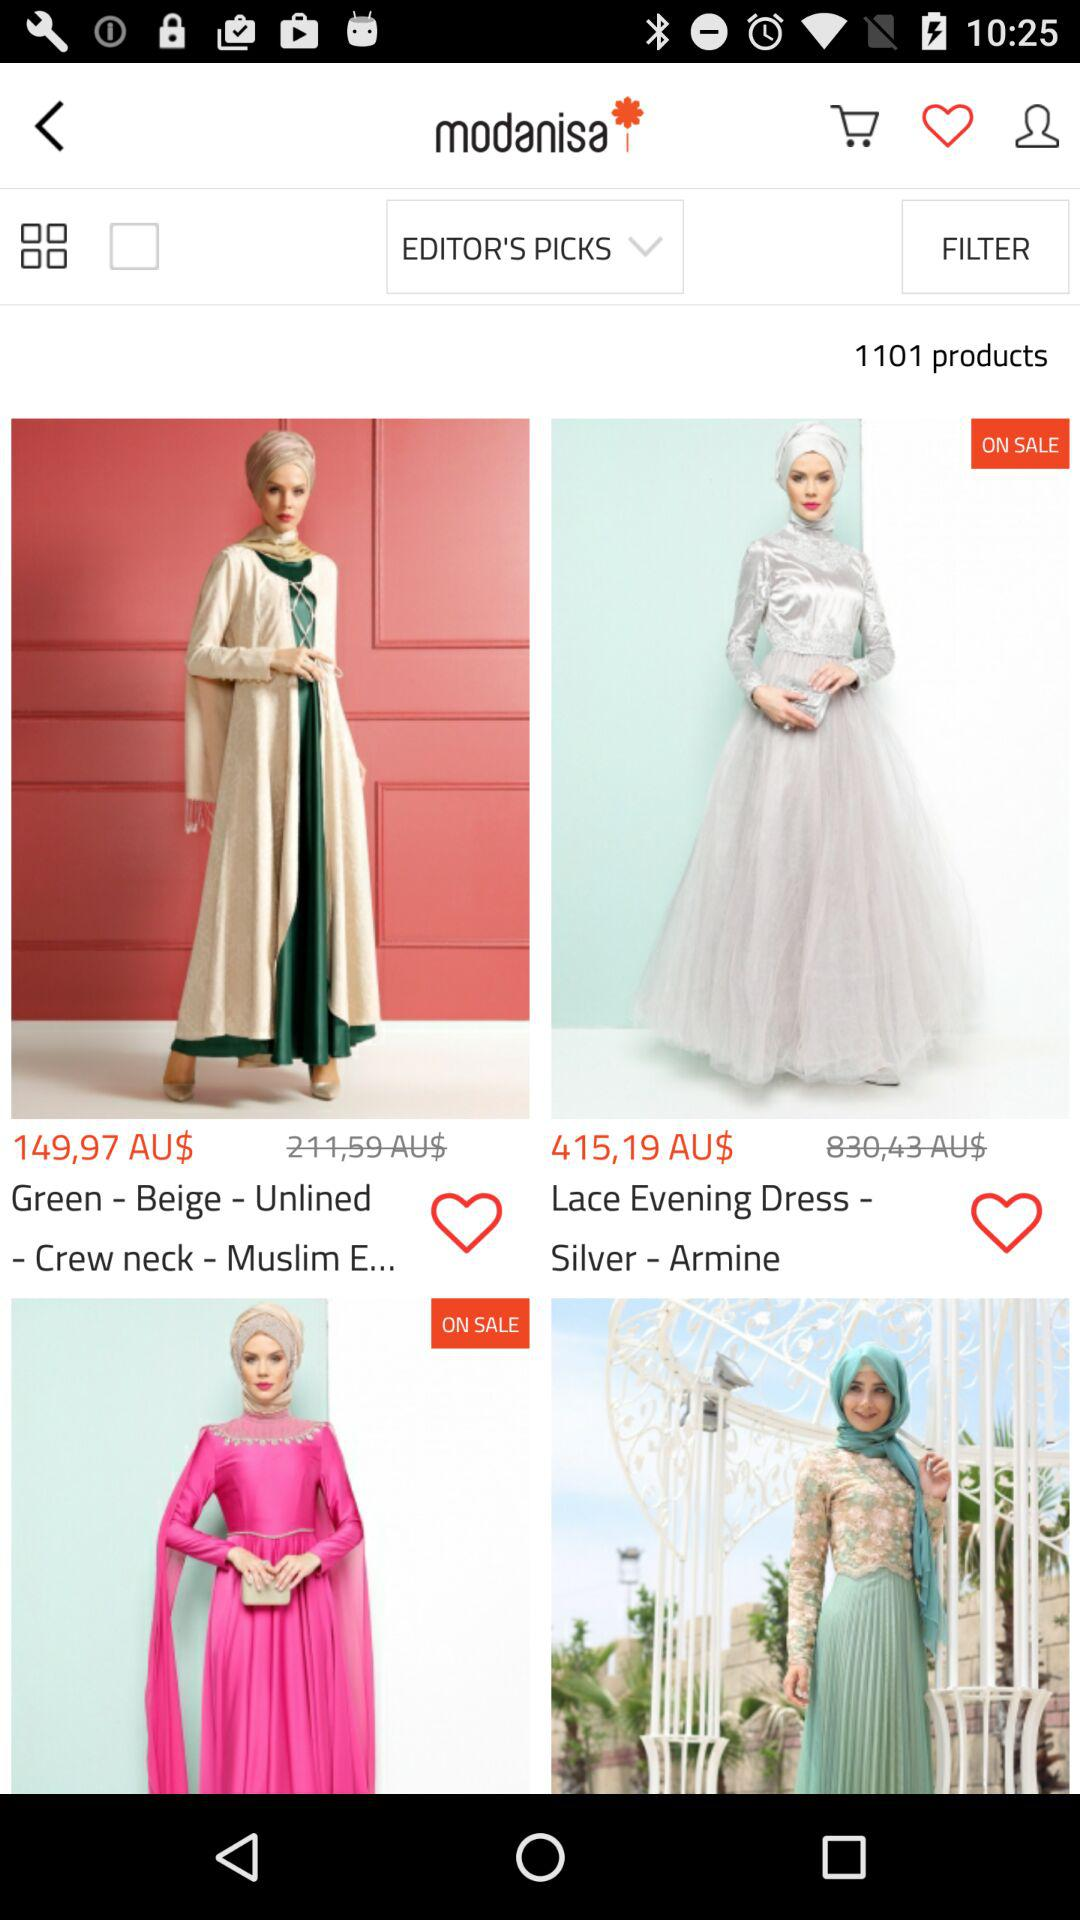What is the name of the dress that is on sale? The name of the dress is "Lace Evening Dress - Silver - Armine". 